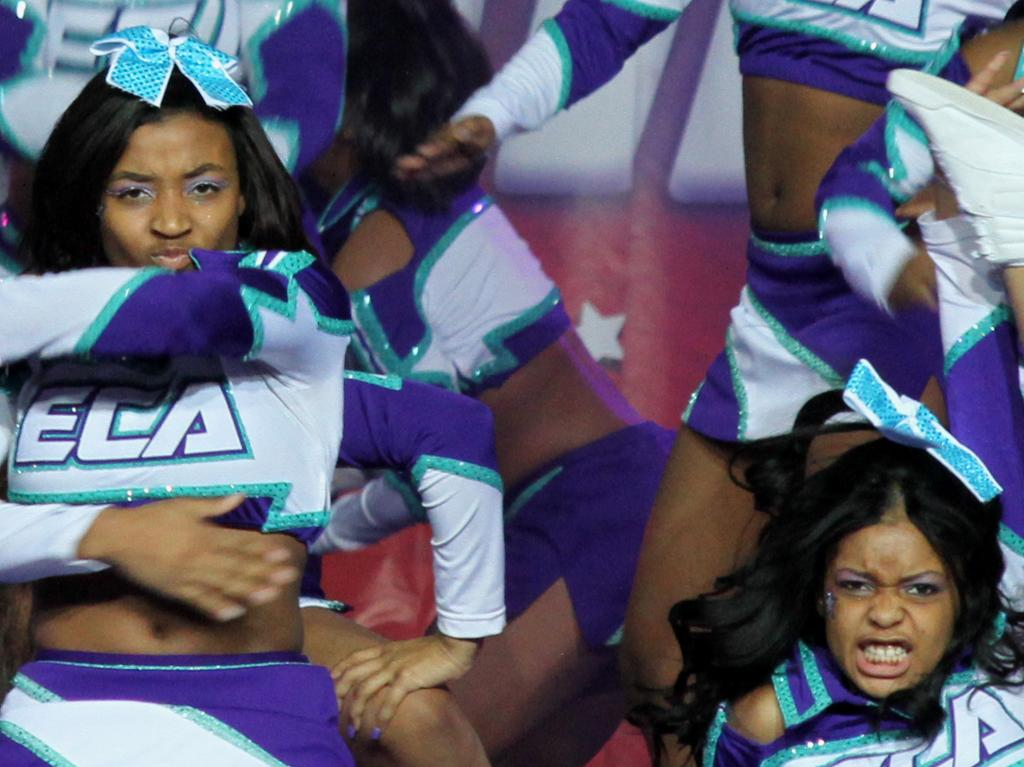<image>
Write a terse but informative summary of the picture. many cheerleaders with on wearing an outfit with eca on it 